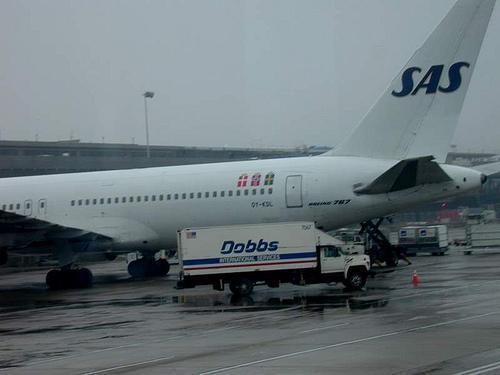How many wings does it have?
Give a very brief answer. 2. How many trucks in front of the airplane?
Give a very brief answer. 1. 